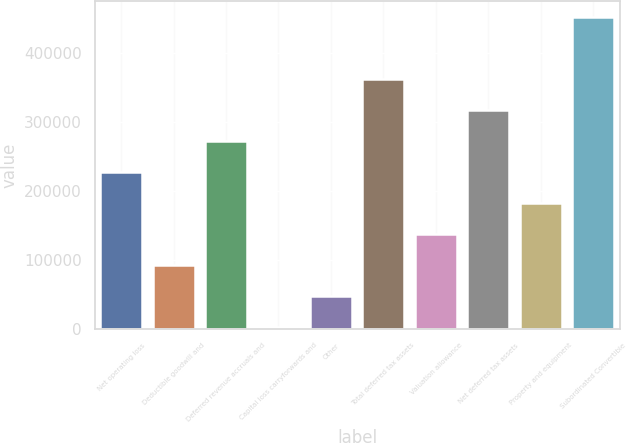Convert chart to OTSL. <chart><loc_0><loc_0><loc_500><loc_500><bar_chart><fcel>Net operating loss<fcel>Deductible goodwill and<fcel>Deferred revenue accruals and<fcel>Capital loss carryforwards and<fcel>Other<fcel>Total deferred tax assets<fcel>Valuation allowance<fcel>Net deferred tax assets<fcel>Property and equipment<fcel>Subordinated Convertible<nl><fcel>227697<fcel>93118.8<fcel>272556<fcel>3400<fcel>48259.4<fcel>362275<fcel>137978<fcel>317416<fcel>182838<fcel>451994<nl></chart> 